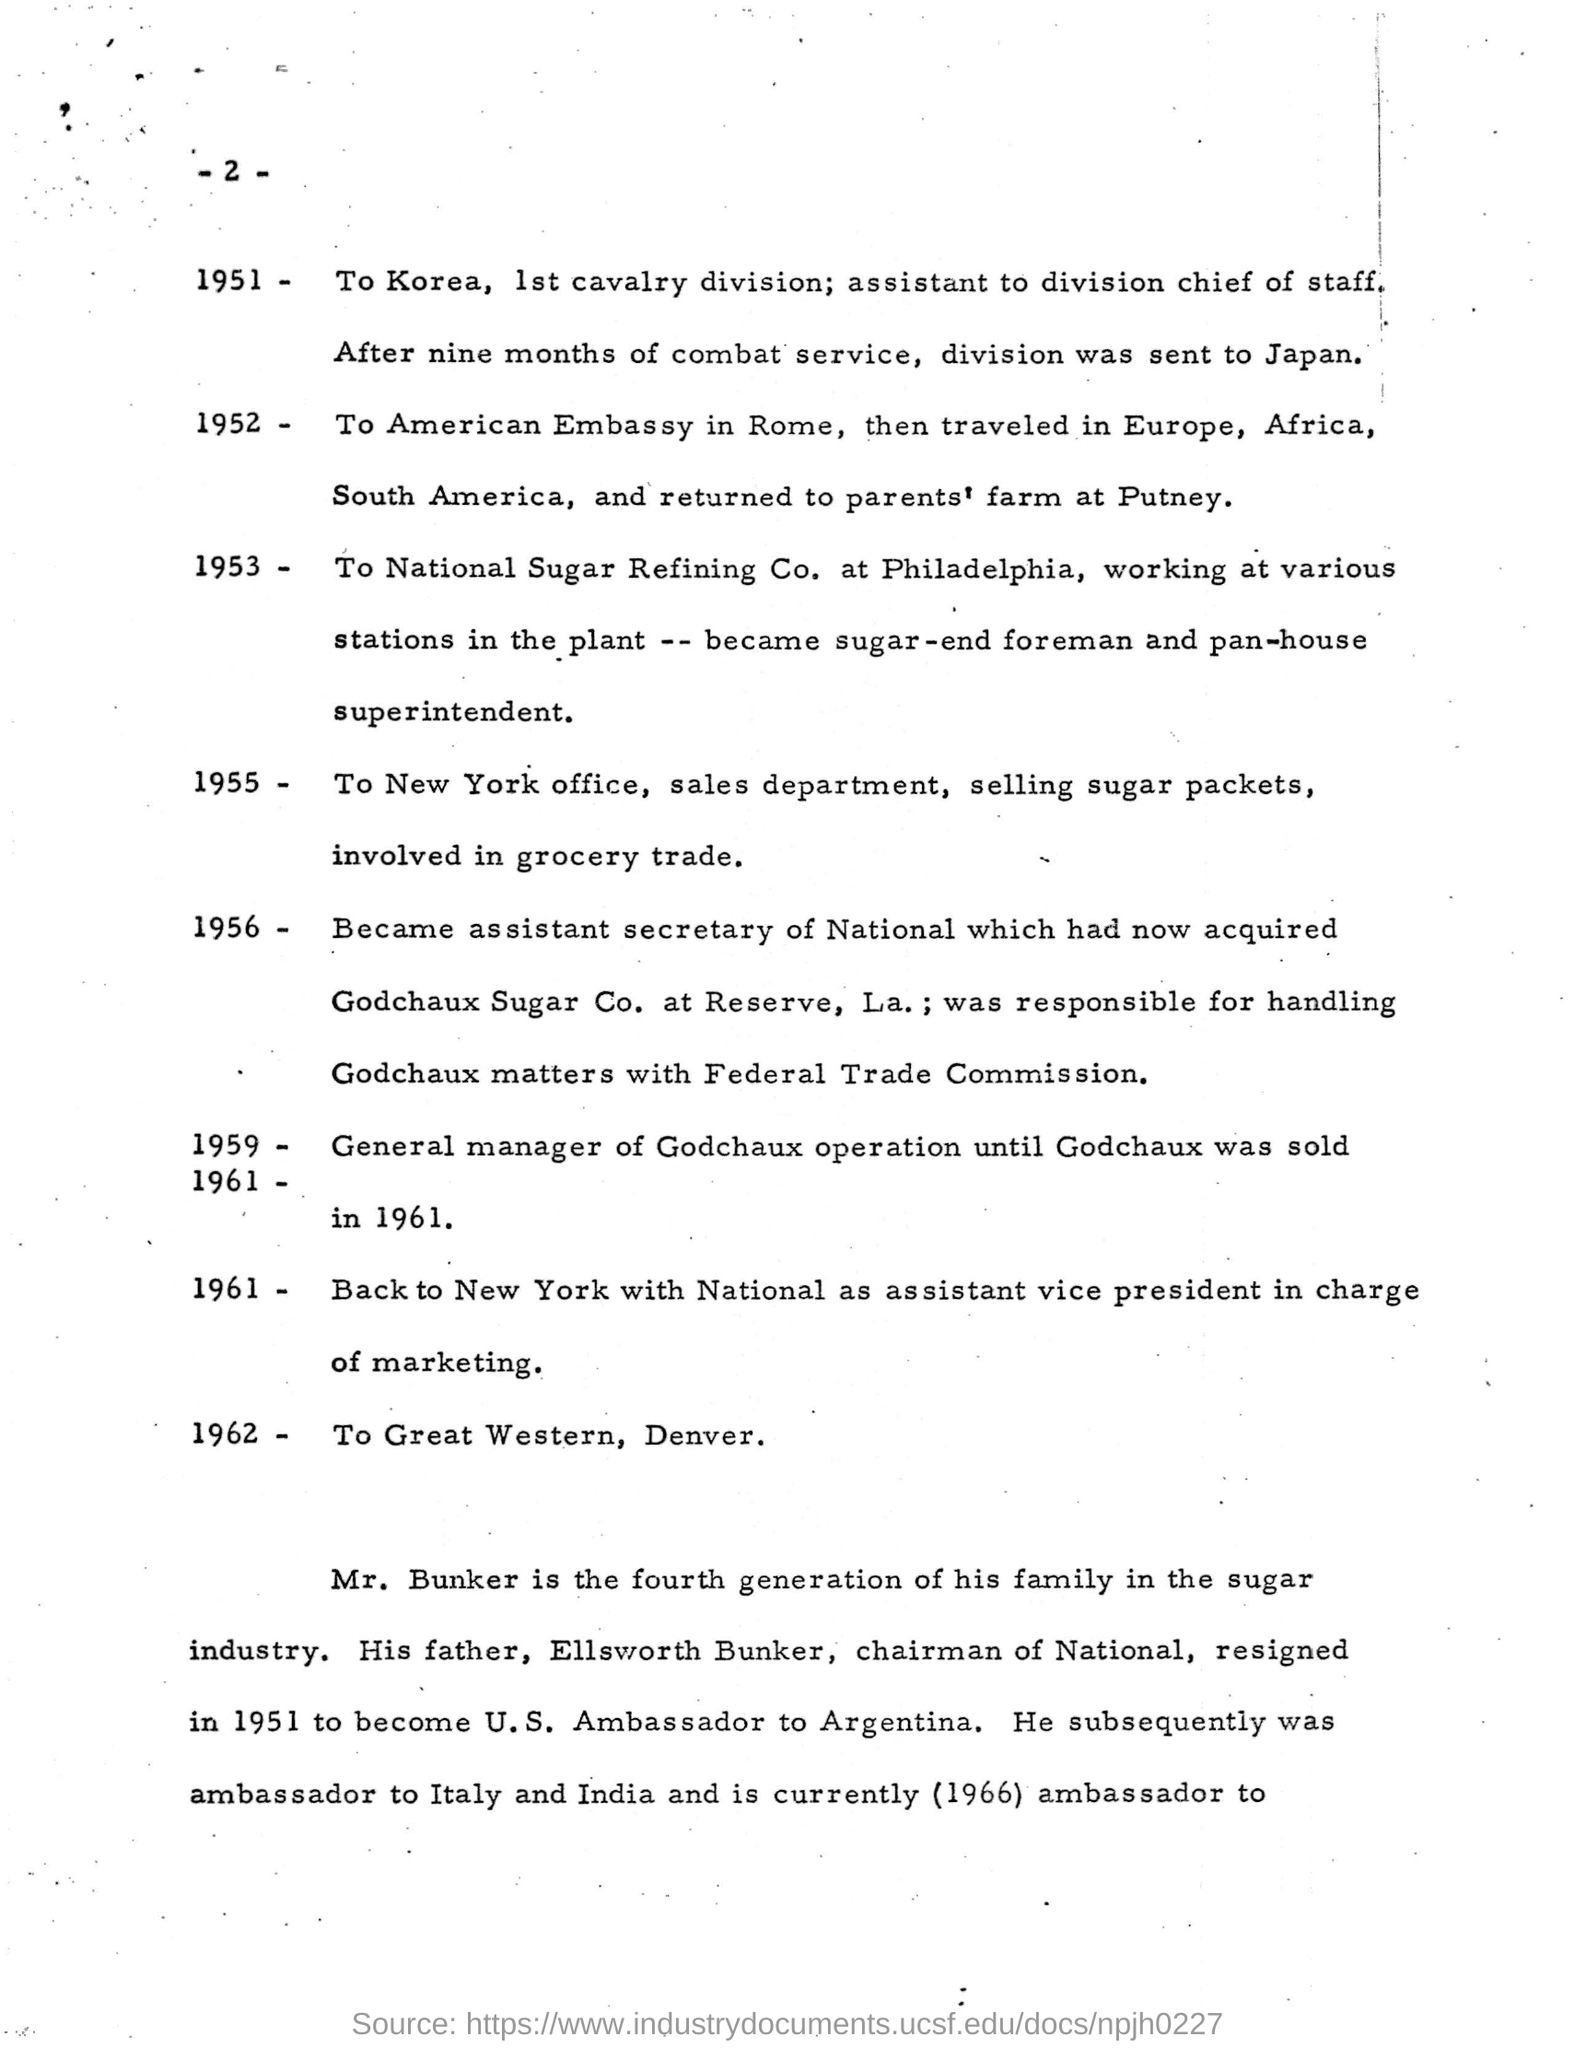After how many months is the division sent to japan?
Your answer should be very brief. Nine months. Which year is mentioned referring to the New York office, Sales Department?
Offer a terse response. 1955. Which generation of the family is Mr.Bunker?
Your answer should be compact. Fourth. Who is the father of mr.bunker?
Your answer should be compact. Ellsworth Bunker. 